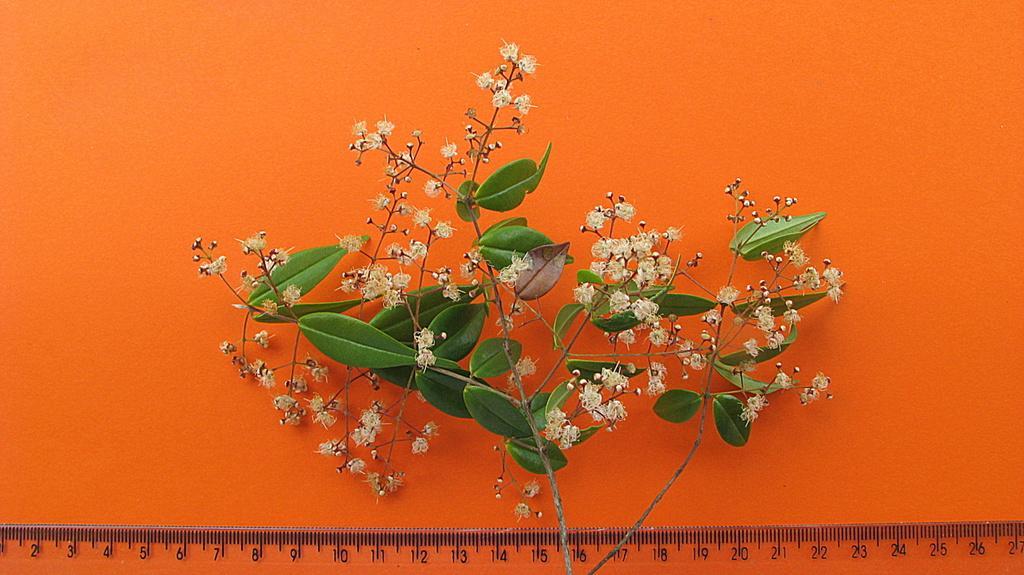Please provide a concise description of this image. In this picture there is a plant. At the bottom there is a scale. At the back there is a orange color background. 